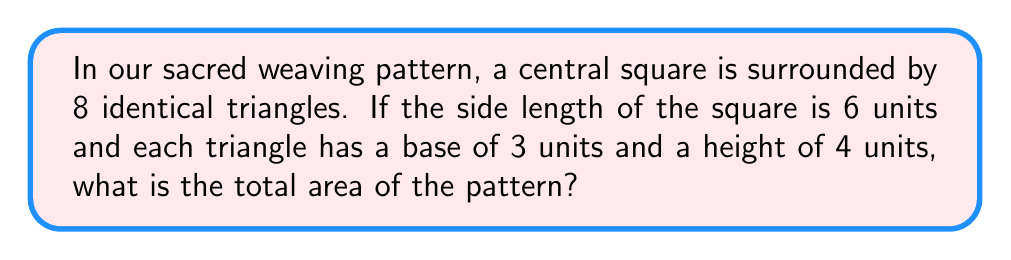Can you solve this math problem? Let's approach this step-by-step:

1. Area of the central square:
   $$A_{square} = s^2 = 6^2 = 36 \text{ square units}$$

2. Area of each triangle:
   $$A_{triangle} = \frac{1}{2} \times base \times height = \frac{1}{2} \times 3 \times 4 = 6 \text{ square units}$$

3. Total area of all 8 triangles:
   $$A_{all triangles} = 8 \times A_{triangle} = 8 \times 6 = 48 \text{ square units}$$

4. Total area of the entire pattern:
   $$A_{total} = A_{square} + A_{all triangles} = 36 + 48 = 84 \text{ square units}$$

The symmetry in this pattern is evident in the equal number of triangles on each side of the square, and the repetition is seen in the use of identical triangles around the central square.
Answer: 84 square units 